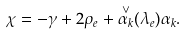Convert formula to latex. <formula><loc_0><loc_0><loc_500><loc_500>\chi = - \gamma + 2 \rho _ { e } + \overset { \vee } { \alpha _ { k } } ( \lambda _ { e } ) \alpha _ { k } .</formula> 